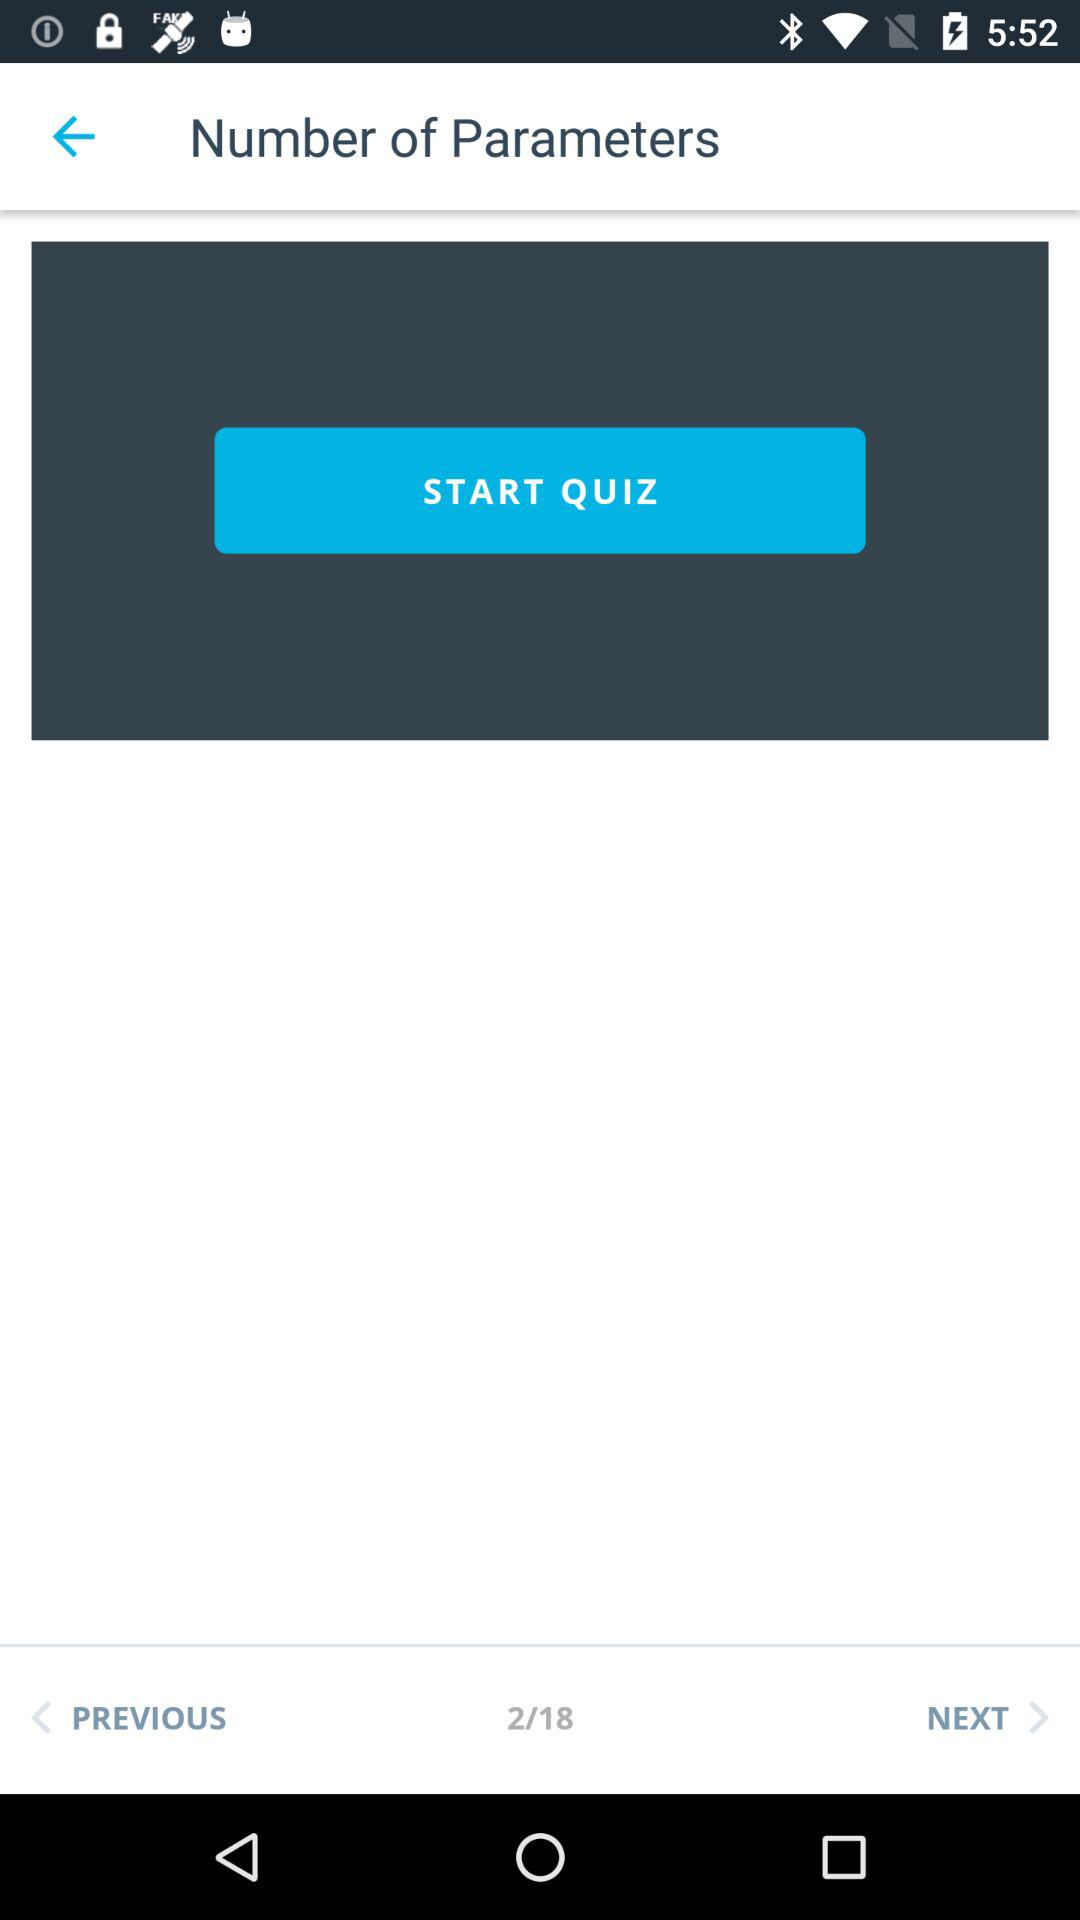On which page are we currently? You are on the second page. 